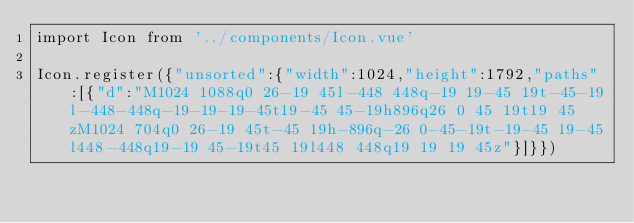<code> <loc_0><loc_0><loc_500><loc_500><_JavaScript_>import Icon from '../components/Icon.vue'

Icon.register({"unsorted":{"width":1024,"height":1792,"paths":[{"d":"M1024 1088q0 26-19 45l-448 448q-19 19-45 19t-45-19l-448-448q-19-19-19-45t19-45 45-19h896q26 0 45 19t19 45zM1024 704q0 26-19 45t-45 19h-896q-26 0-45-19t-19-45 19-45l448-448q19-19 45-19t45 19l448 448q19 19 19 45z"}]}})</code> 